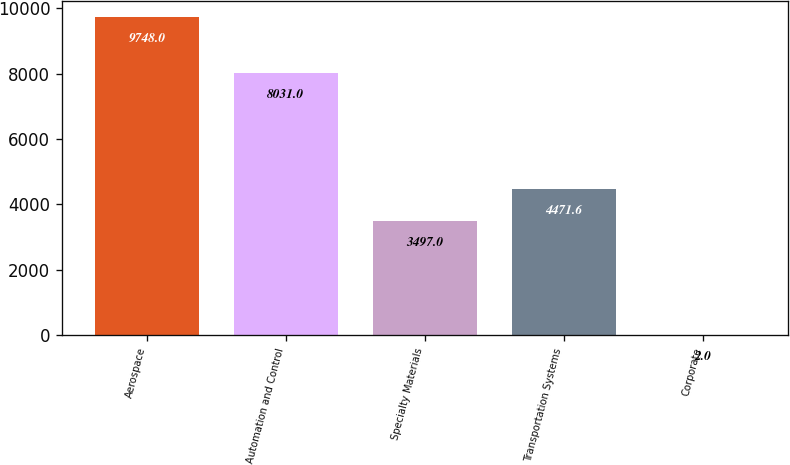Convert chart. <chart><loc_0><loc_0><loc_500><loc_500><bar_chart><fcel>Aerospace<fcel>Automation and Control<fcel>Specialty Materials<fcel>Transportation Systems<fcel>Corporate<nl><fcel>9748<fcel>8031<fcel>3497<fcel>4471.6<fcel>2<nl></chart> 